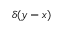Convert formula to latex. <formula><loc_0><loc_0><loc_500><loc_500>\delta ( y - x )</formula> 